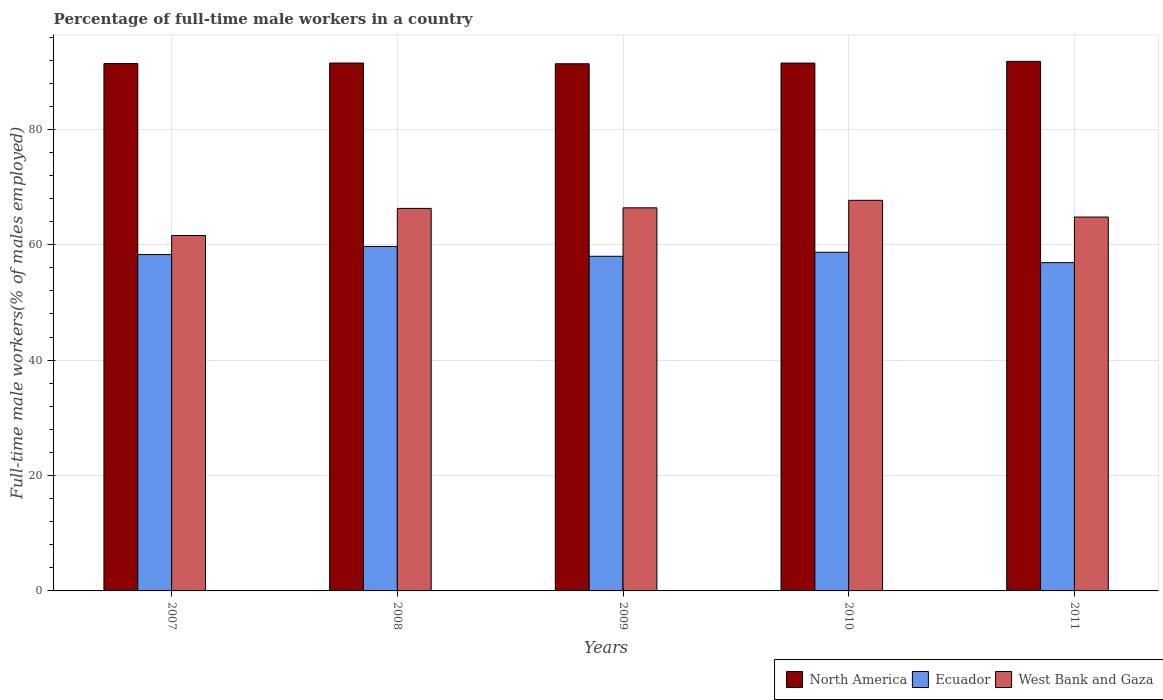Are the number of bars per tick equal to the number of legend labels?
Provide a short and direct response. Yes. Are the number of bars on each tick of the X-axis equal?
Offer a terse response. Yes. How many bars are there on the 1st tick from the left?
Your answer should be compact. 3. What is the percentage of full-time male workers in North America in 2011?
Your response must be concise. 91.79. Across all years, what is the maximum percentage of full-time male workers in West Bank and Gaza?
Offer a terse response. 67.7. Across all years, what is the minimum percentage of full-time male workers in Ecuador?
Give a very brief answer. 56.9. In which year was the percentage of full-time male workers in West Bank and Gaza maximum?
Keep it short and to the point. 2010. In which year was the percentage of full-time male workers in Ecuador minimum?
Provide a succinct answer. 2011. What is the total percentage of full-time male workers in North America in the graph?
Give a very brief answer. 457.53. What is the difference between the percentage of full-time male workers in Ecuador in 2009 and that in 2011?
Your response must be concise. 1.1. What is the difference between the percentage of full-time male workers in Ecuador in 2008 and the percentage of full-time male workers in North America in 2009?
Provide a succinct answer. -31.67. What is the average percentage of full-time male workers in Ecuador per year?
Give a very brief answer. 58.32. In the year 2011, what is the difference between the percentage of full-time male workers in North America and percentage of full-time male workers in West Bank and Gaza?
Your response must be concise. 26.99. What is the ratio of the percentage of full-time male workers in West Bank and Gaza in 2007 to that in 2008?
Provide a short and direct response. 0.93. What is the difference between the highest and the second highest percentage of full-time male workers in North America?
Ensure brevity in your answer.  0.29. What is the difference between the highest and the lowest percentage of full-time male workers in West Bank and Gaza?
Ensure brevity in your answer.  6.1. Is the sum of the percentage of full-time male workers in West Bank and Gaza in 2009 and 2011 greater than the maximum percentage of full-time male workers in North America across all years?
Your response must be concise. Yes. What does the 2nd bar from the left in 2011 represents?
Give a very brief answer. Ecuador. What does the 1st bar from the right in 2008 represents?
Make the answer very short. West Bank and Gaza. How many bars are there?
Give a very brief answer. 15. Are all the bars in the graph horizontal?
Ensure brevity in your answer.  No. What is the difference between two consecutive major ticks on the Y-axis?
Make the answer very short. 20. Are the values on the major ticks of Y-axis written in scientific E-notation?
Provide a succinct answer. No. Does the graph contain grids?
Your answer should be compact. Yes. Where does the legend appear in the graph?
Your answer should be compact. Bottom right. How many legend labels are there?
Give a very brief answer. 3. How are the legend labels stacked?
Your answer should be very brief. Horizontal. What is the title of the graph?
Provide a succinct answer. Percentage of full-time male workers in a country. What is the label or title of the Y-axis?
Ensure brevity in your answer.  Full-time male workers(% of males employed). What is the Full-time male workers(% of males employed) of North America in 2007?
Ensure brevity in your answer.  91.4. What is the Full-time male workers(% of males employed) in Ecuador in 2007?
Your answer should be very brief. 58.3. What is the Full-time male workers(% of males employed) of West Bank and Gaza in 2007?
Ensure brevity in your answer.  61.6. What is the Full-time male workers(% of males employed) in North America in 2008?
Keep it short and to the point. 91.49. What is the Full-time male workers(% of males employed) of Ecuador in 2008?
Your response must be concise. 59.7. What is the Full-time male workers(% of males employed) of West Bank and Gaza in 2008?
Give a very brief answer. 66.3. What is the Full-time male workers(% of males employed) of North America in 2009?
Offer a very short reply. 91.37. What is the Full-time male workers(% of males employed) in Ecuador in 2009?
Keep it short and to the point. 58. What is the Full-time male workers(% of males employed) of West Bank and Gaza in 2009?
Offer a terse response. 66.4. What is the Full-time male workers(% of males employed) of North America in 2010?
Offer a very short reply. 91.49. What is the Full-time male workers(% of males employed) of Ecuador in 2010?
Provide a short and direct response. 58.7. What is the Full-time male workers(% of males employed) in West Bank and Gaza in 2010?
Give a very brief answer. 67.7. What is the Full-time male workers(% of males employed) in North America in 2011?
Ensure brevity in your answer.  91.79. What is the Full-time male workers(% of males employed) of Ecuador in 2011?
Offer a terse response. 56.9. What is the Full-time male workers(% of males employed) in West Bank and Gaza in 2011?
Provide a short and direct response. 64.8. Across all years, what is the maximum Full-time male workers(% of males employed) in North America?
Make the answer very short. 91.79. Across all years, what is the maximum Full-time male workers(% of males employed) of Ecuador?
Your response must be concise. 59.7. Across all years, what is the maximum Full-time male workers(% of males employed) of West Bank and Gaza?
Ensure brevity in your answer.  67.7. Across all years, what is the minimum Full-time male workers(% of males employed) in North America?
Provide a short and direct response. 91.37. Across all years, what is the minimum Full-time male workers(% of males employed) of Ecuador?
Offer a very short reply. 56.9. Across all years, what is the minimum Full-time male workers(% of males employed) in West Bank and Gaza?
Make the answer very short. 61.6. What is the total Full-time male workers(% of males employed) in North America in the graph?
Your response must be concise. 457.53. What is the total Full-time male workers(% of males employed) of Ecuador in the graph?
Your answer should be very brief. 291.6. What is the total Full-time male workers(% of males employed) in West Bank and Gaza in the graph?
Your answer should be compact. 326.8. What is the difference between the Full-time male workers(% of males employed) in North America in 2007 and that in 2008?
Provide a short and direct response. -0.1. What is the difference between the Full-time male workers(% of males employed) of Ecuador in 2007 and that in 2008?
Your answer should be very brief. -1.4. What is the difference between the Full-time male workers(% of males employed) of West Bank and Gaza in 2007 and that in 2008?
Offer a terse response. -4.7. What is the difference between the Full-time male workers(% of males employed) in North America in 2007 and that in 2009?
Your answer should be very brief. 0.03. What is the difference between the Full-time male workers(% of males employed) of Ecuador in 2007 and that in 2009?
Provide a short and direct response. 0.3. What is the difference between the Full-time male workers(% of males employed) in North America in 2007 and that in 2010?
Ensure brevity in your answer.  -0.09. What is the difference between the Full-time male workers(% of males employed) of North America in 2007 and that in 2011?
Your response must be concise. -0.39. What is the difference between the Full-time male workers(% of males employed) in West Bank and Gaza in 2007 and that in 2011?
Provide a short and direct response. -3.2. What is the difference between the Full-time male workers(% of males employed) of North America in 2008 and that in 2009?
Ensure brevity in your answer.  0.12. What is the difference between the Full-time male workers(% of males employed) of North America in 2008 and that in 2010?
Your response must be concise. 0.01. What is the difference between the Full-time male workers(% of males employed) of Ecuador in 2008 and that in 2010?
Your response must be concise. 1. What is the difference between the Full-time male workers(% of males employed) in North America in 2008 and that in 2011?
Make the answer very short. -0.29. What is the difference between the Full-time male workers(% of males employed) in North America in 2009 and that in 2010?
Your answer should be very brief. -0.12. What is the difference between the Full-time male workers(% of males employed) of North America in 2009 and that in 2011?
Keep it short and to the point. -0.42. What is the difference between the Full-time male workers(% of males employed) of Ecuador in 2009 and that in 2011?
Keep it short and to the point. 1.1. What is the difference between the Full-time male workers(% of males employed) of West Bank and Gaza in 2009 and that in 2011?
Make the answer very short. 1.6. What is the difference between the Full-time male workers(% of males employed) in North America in 2010 and that in 2011?
Provide a succinct answer. -0.3. What is the difference between the Full-time male workers(% of males employed) of Ecuador in 2010 and that in 2011?
Keep it short and to the point. 1.8. What is the difference between the Full-time male workers(% of males employed) of North America in 2007 and the Full-time male workers(% of males employed) of Ecuador in 2008?
Provide a short and direct response. 31.7. What is the difference between the Full-time male workers(% of males employed) of North America in 2007 and the Full-time male workers(% of males employed) of West Bank and Gaza in 2008?
Keep it short and to the point. 25.1. What is the difference between the Full-time male workers(% of males employed) in North America in 2007 and the Full-time male workers(% of males employed) in Ecuador in 2009?
Provide a succinct answer. 33.4. What is the difference between the Full-time male workers(% of males employed) of North America in 2007 and the Full-time male workers(% of males employed) of West Bank and Gaza in 2009?
Make the answer very short. 25. What is the difference between the Full-time male workers(% of males employed) of North America in 2007 and the Full-time male workers(% of males employed) of Ecuador in 2010?
Give a very brief answer. 32.7. What is the difference between the Full-time male workers(% of males employed) in North America in 2007 and the Full-time male workers(% of males employed) in West Bank and Gaza in 2010?
Offer a terse response. 23.7. What is the difference between the Full-time male workers(% of males employed) in North America in 2007 and the Full-time male workers(% of males employed) in Ecuador in 2011?
Your answer should be compact. 34.5. What is the difference between the Full-time male workers(% of males employed) in North America in 2007 and the Full-time male workers(% of males employed) in West Bank and Gaza in 2011?
Give a very brief answer. 26.6. What is the difference between the Full-time male workers(% of males employed) of North America in 2008 and the Full-time male workers(% of males employed) of Ecuador in 2009?
Provide a short and direct response. 33.49. What is the difference between the Full-time male workers(% of males employed) of North America in 2008 and the Full-time male workers(% of males employed) of West Bank and Gaza in 2009?
Your response must be concise. 25.09. What is the difference between the Full-time male workers(% of males employed) of North America in 2008 and the Full-time male workers(% of males employed) of Ecuador in 2010?
Offer a terse response. 32.79. What is the difference between the Full-time male workers(% of males employed) of North America in 2008 and the Full-time male workers(% of males employed) of West Bank and Gaza in 2010?
Make the answer very short. 23.79. What is the difference between the Full-time male workers(% of males employed) of Ecuador in 2008 and the Full-time male workers(% of males employed) of West Bank and Gaza in 2010?
Your response must be concise. -8. What is the difference between the Full-time male workers(% of males employed) in North America in 2008 and the Full-time male workers(% of males employed) in Ecuador in 2011?
Make the answer very short. 34.59. What is the difference between the Full-time male workers(% of males employed) of North America in 2008 and the Full-time male workers(% of males employed) of West Bank and Gaza in 2011?
Provide a succinct answer. 26.69. What is the difference between the Full-time male workers(% of males employed) in Ecuador in 2008 and the Full-time male workers(% of males employed) in West Bank and Gaza in 2011?
Make the answer very short. -5.1. What is the difference between the Full-time male workers(% of males employed) of North America in 2009 and the Full-time male workers(% of males employed) of Ecuador in 2010?
Ensure brevity in your answer.  32.67. What is the difference between the Full-time male workers(% of males employed) in North America in 2009 and the Full-time male workers(% of males employed) in West Bank and Gaza in 2010?
Offer a very short reply. 23.67. What is the difference between the Full-time male workers(% of males employed) in North America in 2009 and the Full-time male workers(% of males employed) in Ecuador in 2011?
Offer a very short reply. 34.47. What is the difference between the Full-time male workers(% of males employed) in North America in 2009 and the Full-time male workers(% of males employed) in West Bank and Gaza in 2011?
Your response must be concise. 26.57. What is the difference between the Full-time male workers(% of males employed) in Ecuador in 2009 and the Full-time male workers(% of males employed) in West Bank and Gaza in 2011?
Your answer should be very brief. -6.8. What is the difference between the Full-time male workers(% of males employed) in North America in 2010 and the Full-time male workers(% of males employed) in Ecuador in 2011?
Your answer should be very brief. 34.59. What is the difference between the Full-time male workers(% of males employed) of North America in 2010 and the Full-time male workers(% of males employed) of West Bank and Gaza in 2011?
Your answer should be compact. 26.69. What is the average Full-time male workers(% of males employed) in North America per year?
Provide a short and direct response. 91.51. What is the average Full-time male workers(% of males employed) in Ecuador per year?
Provide a short and direct response. 58.32. What is the average Full-time male workers(% of males employed) in West Bank and Gaza per year?
Give a very brief answer. 65.36. In the year 2007, what is the difference between the Full-time male workers(% of males employed) of North America and Full-time male workers(% of males employed) of Ecuador?
Ensure brevity in your answer.  33.1. In the year 2007, what is the difference between the Full-time male workers(% of males employed) of North America and Full-time male workers(% of males employed) of West Bank and Gaza?
Give a very brief answer. 29.8. In the year 2008, what is the difference between the Full-time male workers(% of males employed) in North America and Full-time male workers(% of males employed) in Ecuador?
Your response must be concise. 31.79. In the year 2008, what is the difference between the Full-time male workers(% of males employed) of North America and Full-time male workers(% of males employed) of West Bank and Gaza?
Provide a succinct answer. 25.19. In the year 2008, what is the difference between the Full-time male workers(% of males employed) of Ecuador and Full-time male workers(% of males employed) of West Bank and Gaza?
Ensure brevity in your answer.  -6.6. In the year 2009, what is the difference between the Full-time male workers(% of males employed) of North America and Full-time male workers(% of males employed) of Ecuador?
Your answer should be very brief. 33.37. In the year 2009, what is the difference between the Full-time male workers(% of males employed) of North America and Full-time male workers(% of males employed) of West Bank and Gaza?
Keep it short and to the point. 24.97. In the year 2009, what is the difference between the Full-time male workers(% of males employed) in Ecuador and Full-time male workers(% of males employed) in West Bank and Gaza?
Give a very brief answer. -8.4. In the year 2010, what is the difference between the Full-time male workers(% of males employed) of North America and Full-time male workers(% of males employed) of Ecuador?
Your response must be concise. 32.79. In the year 2010, what is the difference between the Full-time male workers(% of males employed) in North America and Full-time male workers(% of males employed) in West Bank and Gaza?
Give a very brief answer. 23.79. In the year 2011, what is the difference between the Full-time male workers(% of males employed) in North America and Full-time male workers(% of males employed) in Ecuador?
Offer a very short reply. 34.89. In the year 2011, what is the difference between the Full-time male workers(% of males employed) of North America and Full-time male workers(% of males employed) of West Bank and Gaza?
Keep it short and to the point. 26.99. What is the ratio of the Full-time male workers(% of males employed) of Ecuador in 2007 to that in 2008?
Provide a succinct answer. 0.98. What is the ratio of the Full-time male workers(% of males employed) of West Bank and Gaza in 2007 to that in 2008?
Your answer should be compact. 0.93. What is the ratio of the Full-time male workers(% of males employed) in Ecuador in 2007 to that in 2009?
Your answer should be very brief. 1.01. What is the ratio of the Full-time male workers(% of males employed) of West Bank and Gaza in 2007 to that in 2009?
Give a very brief answer. 0.93. What is the ratio of the Full-time male workers(% of males employed) in North America in 2007 to that in 2010?
Make the answer very short. 1. What is the ratio of the Full-time male workers(% of males employed) of West Bank and Gaza in 2007 to that in 2010?
Provide a succinct answer. 0.91. What is the ratio of the Full-time male workers(% of males employed) of Ecuador in 2007 to that in 2011?
Offer a terse response. 1.02. What is the ratio of the Full-time male workers(% of males employed) in West Bank and Gaza in 2007 to that in 2011?
Your response must be concise. 0.95. What is the ratio of the Full-time male workers(% of males employed) of North America in 2008 to that in 2009?
Keep it short and to the point. 1. What is the ratio of the Full-time male workers(% of males employed) in Ecuador in 2008 to that in 2009?
Your answer should be compact. 1.03. What is the ratio of the Full-time male workers(% of males employed) of West Bank and Gaza in 2008 to that in 2009?
Your response must be concise. 1. What is the ratio of the Full-time male workers(% of males employed) in Ecuador in 2008 to that in 2010?
Offer a terse response. 1.02. What is the ratio of the Full-time male workers(% of males employed) in West Bank and Gaza in 2008 to that in 2010?
Offer a terse response. 0.98. What is the ratio of the Full-time male workers(% of males employed) of Ecuador in 2008 to that in 2011?
Make the answer very short. 1.05. What is the ratio of the Full-time male workers(% of males employed) of West Bank and Gaza in 2008 to that in 2011?
Your answer should be compact. 1.02. What is the ratio of the Full-time male workers(% of males employed) in Ecuador in 2009 to that in 2010?
Provide a short and direct response. 0.99. What is the ratio of the Full-time male workers(% of males employed) in West Bank and Gaza in 2009 to that in 2010?
Provide a short and direct response. 0.98. What is the ratio of the Full-time male workers(% of males employed) in Ecuador in 2009 to that in 2011?
Keep it short and to the point. 1.02. What is the ratio of the Full-time male workers(% of males employed) in West Bank and Gaza in 2009 to that in 2011?
Offer a very short reply. 1.02. What is the ratio of the Full-time male workers(% of males employed) in Ecuador in 2010 to that in 2011?
Provide a succinct answer. 1.03. What is the ratio of the Full-time male workers(% of males employed) in West Bank and Gaza in 2010 to that in 2011?
Provide a succinct answer. 1.04. What is the difference between the highest and the second highest Full-time male workers(% of males employed) of North America?
Provide a short and direct response. 0.29. What is the difference between the highest and the second highest Full-time male workers(% of males employed) in Ecuador?
Provide a short and direct response. 1. What is the difference between the highest and the second highest Full-time male workers(% of males employed) of West Bank and Gaza?
Provide a short and direct response. 1.3. What is the difference between the highest and the lowest Full-time male workers(% of males employed) of North America?
Provide a short and direct response. 0.42. What is the difference between the highest and the lowest Full-time male workers(% of males employed) of Ecuador?
Provide a succinct answer. 2.8. 